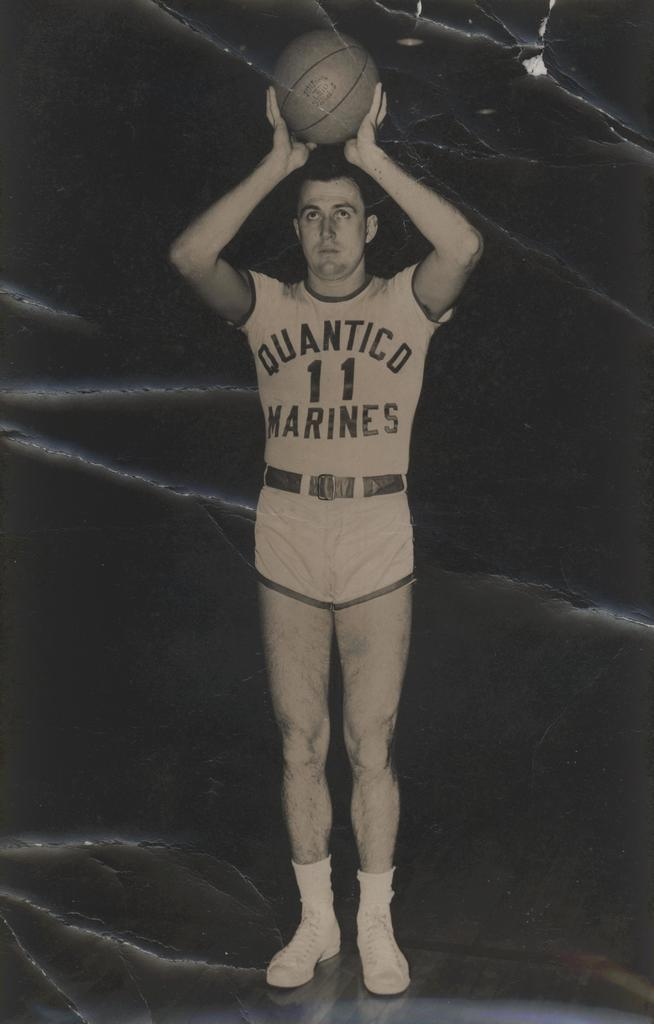<image>
Describe the image concisely. A man is wearing a uniform with Quantico on it. 